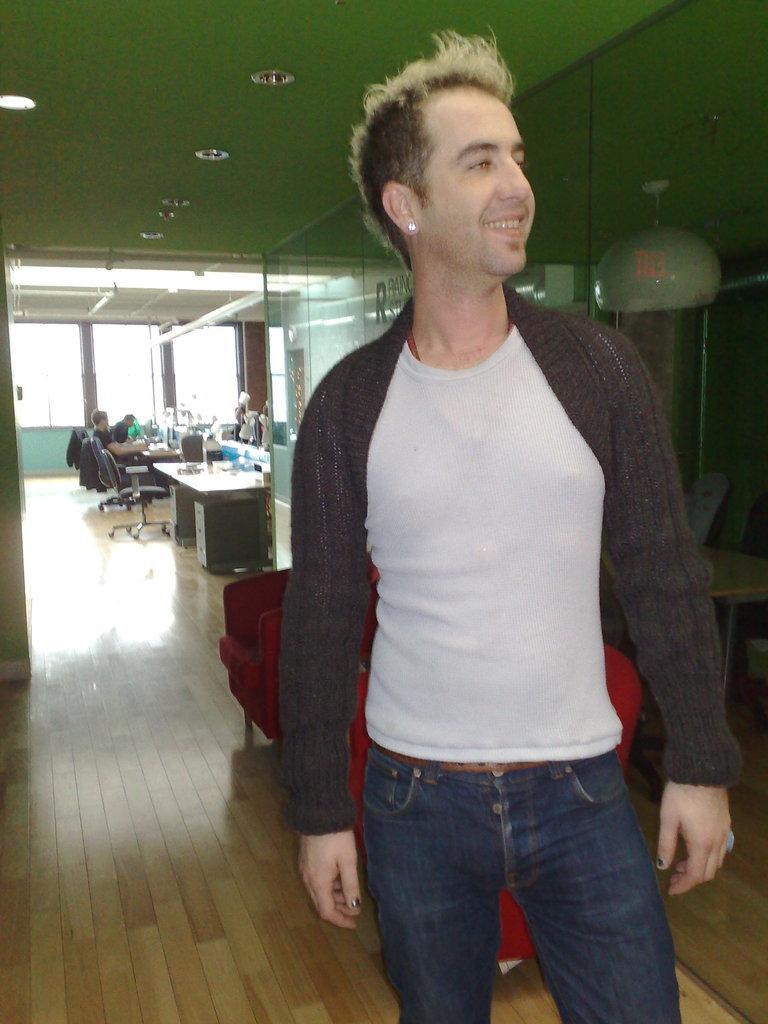Describe this image in one or two sentences. In this picture there is a man standing and smiling. Two men are sitting on the chair. Two jackets are visible on the chair. There is a table, glass , dome lights, Red color chairs are seen. 